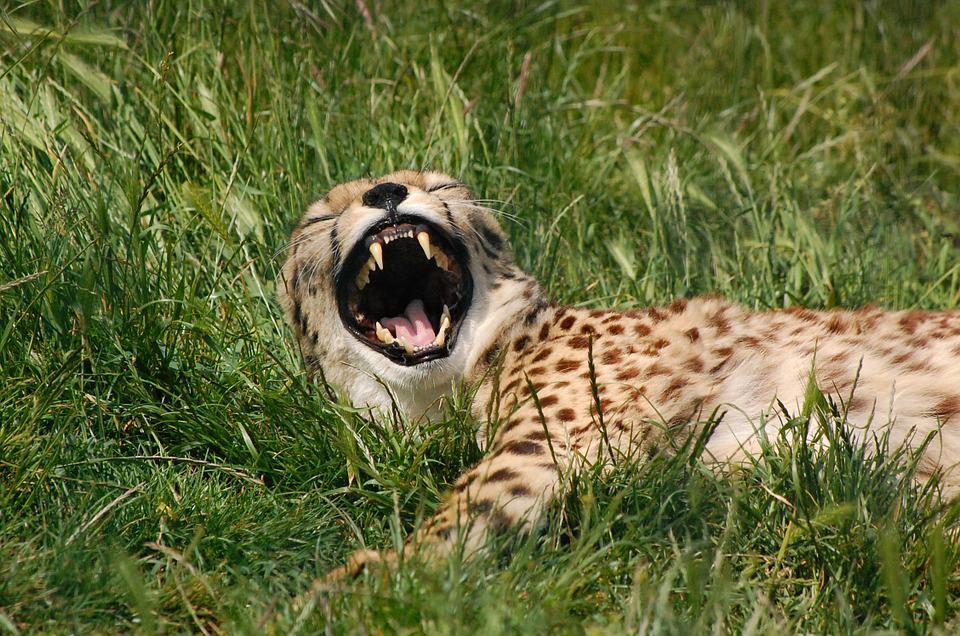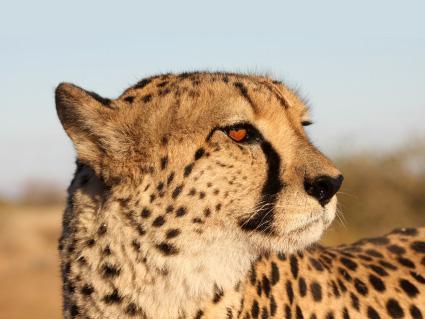The first image is the image on the left, the second image is the image on the right. Considering the images on both sides, is "There are two cats in the image on the right." valid? Answer yes or no. No. 